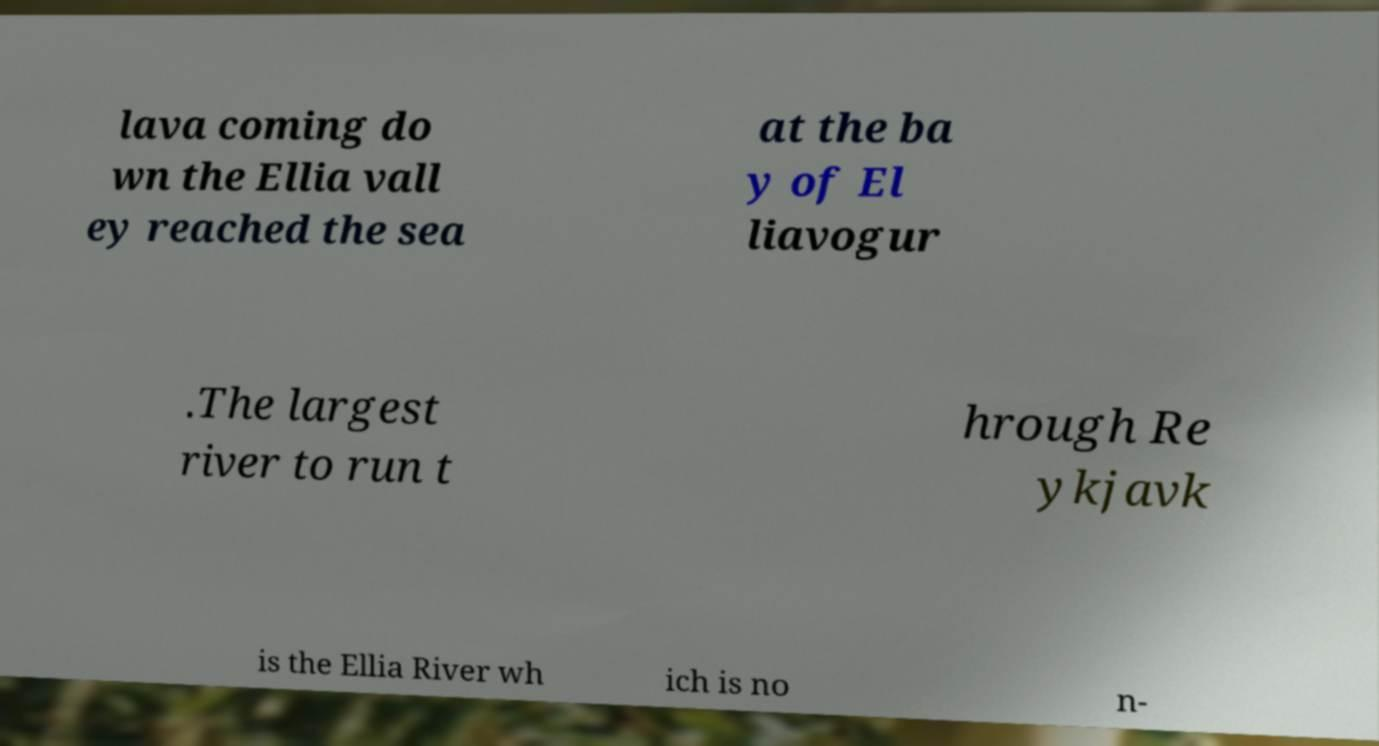Please read and relay the text visible in this image. What does it say? lava coming do wn the Ellia vall ey reached the sea at the ba y of El liavogur .The largest river to run t hrough Re ykjavk is the Ellia River wh ich is no n- 